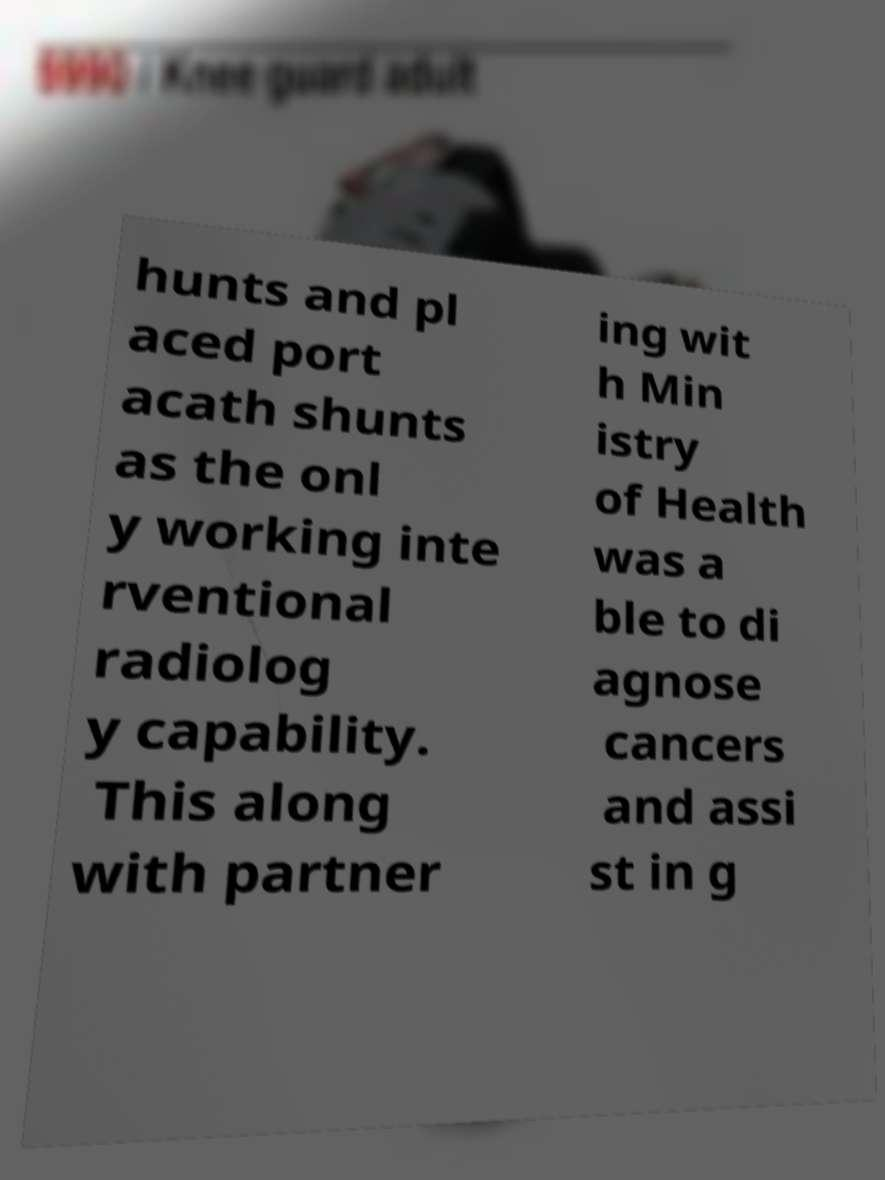Could you extract and type out the text from this image? hunts and pl aced port acath shunts as the onl y working inte rventional radiolog y capability. This along with partner ing wit h Min istry of Health was a ble to di agnose cancers and assi st in g 